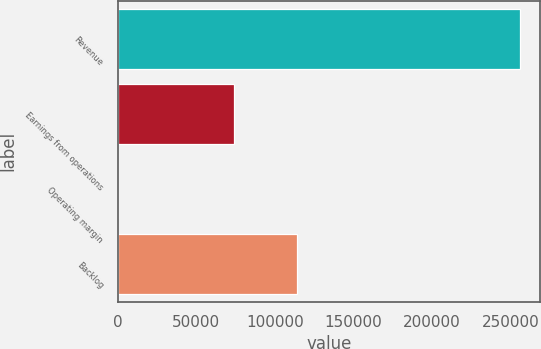Convert chart. <chart><loc_0><loc_0><loc_500><loc_500><bar_chart><fcel>Revenue<fcel>Earnings from operations<fcel>Operating margin<fcel>Backlog<nl><fcel>256102<fcel>74073<fcel>28.9<fcel>114000<nl></chart> 